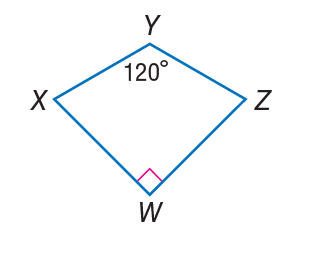Question: If W X Y Z is a kite, find m \angle Z.
Choices:
A. 60
B. 75
C. 120
D. 150
Answer with the letter. Answer: B 